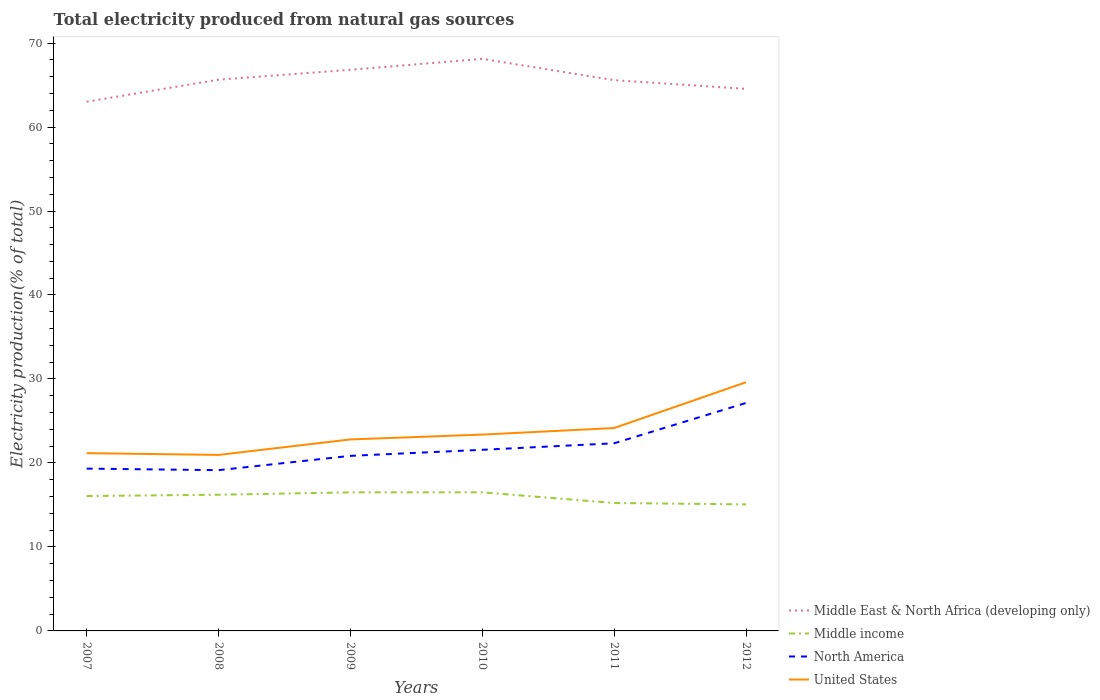How many different coloured lines are there?
Make the answer very short. 4. Does the line corresponding to Middle East & North Africa (developing only) intersect with the line corresponding to United States?
Your answer should be compact. No. Across all years, what is the maximum total electricity produced in North America?
Provide a short and direct response. 19.14. In which year was the total electricity produced in Middle East & North Africa (developing only) maximum?
Ensure brevity in your answer.  2007. What is the total total electricity produced in North America in the graph?
Provide a succinct answer. -4.8. What is the difference between the highest and the second highest total electricity produced in North America?
Your response must be concise. 8. How many lines are there?
Give a very brief answer. 4. How many years are there in the graph?
Make the answer very short. 6. Are the values on the major ticks of Y-axis written in scientific E-notation?
Offer a terse response. No. Does the graph contain grids?
Offer a terse response. No. Where does the legend appear in the graph?
Make the answer very short. Bottom right. How many legend labels are there?
Your answer should be very brief. 4. How are the legend labels stacked?
Your response must be concise. Vertical. What is the title of the graph?
Keep it short and to the point. Total electricity produced from natural gas sources. What is the label or title of the Y-axis?
Your answer should be compact. Electricity production(% of total). What is the Electricity production(% of total) in Middle East & North Africa (developing only) in 2007?
Provide a succinct answer. 63.01. What is the Electricity production(% of total) in Middle income in 2007?
Offer a very short reply. 16.06. What is the Electricity production(% of total) in North America in 2007?
Offer a terse response. 19.32. What is the Electricity production(% of total) of United States in 2007?
Your answer should be compact. 21.17. What is the Electricity production(% of total) in Middle East & North Africa (developing only) in 2008?
Give a very brief answer. 65.64. What is the Electricity production(% of total) in Middle income in 2008?
Offer a very short reply. 16.22. What is the Electricity production(% of total) of North America in 2008?
Give a very brief answer. 19.14. What is the Electricity production(% of total) of United States in 2008?
Keep it short and to the point. 20.96. What is the Electricity production(% of total) in Middle East & North Africa (developing only) in 2009?
Your answer should be compact. 66.81. What is the Electricity production(% of total) of Middle income in 2009?
Your answer should be compact. 16.5. What is the Electricity production(% of total) in North America in 2009?
Ensure brevity in your answer.  20.85. What is the Electricity production(% of total) of United States in 2009?
Ensure brevity in your answer.  22.8. What is the Electricity production(% of total) in Middle East & North Africa (developing only) in 2010?
Provide a short and direct response. 68.12. What is the Electricity production(% of total) in Middle income in 2010?
Offer a terse response. 16.5. What is the Electricity production(% of total) in North America in 2010?
Offer a terse response. 21.57. What is the Electricity production(% of total) in United States in 2010?
Your answer should be very brief. 23.38. What is the Electricity production(% of total) in Middle East & North Africa (developing only) in 2011?
Provide a short and direct response. 65.58. What is the Electricity production(% of total) of Middle income in 2011?
Give a very brief answer. 15.23. What is the Electricity production(% of total) in North America in 2011?
Offer a very short reply. 22.34. What is the Electricity production(% of total) in United States in 2011?
Ensure brevity in your answer.  24.16. What is the Electricity production(% of total) of Middle East & North Africa (developing only) in 2012?
Provide a succinct answer. 64.54. What is the Electricity production(% of total) of Middle income in 2012?
Offer a very short reply. 15.07. What is the Electricity production(% of total) in North America in 2012?
Make the answer very short. 27.15. What is the Electricity production(% of total) in United States in 2012?
Keep it short and to the point. 29.61. Across all years, what is the maximum Electricity production(% of total) of Middle East & North Africa (developing only)?
Your answer should be compact. 68.12. Across all years, what is the maximum Electricity production(% of total) of Middle income?
Provide a short and direct response. 16.5. Across all years, what is the maximum Electricity production(% of total) of North America?
Keep it short and to the point. 27.15. Across all years, what is the maximum Electricity production(% of total) of United States?
Provide a short and direct response. 29.61. Across all years, what is the minimum Electricity production(% of total) in Middle East & North Africa (developing only)?
Ensure brevity in your answer.  63.01. Across all years, what is the minimum Electricity production(% of total) in Middle income?
Keep it short and to the point. 15.07. Across all years, what is the minimum Electricity production(% of total) of North America?
Your answer should be very brief. 19.14. Across all years, what is the minimum Electricity production(% of total) of United States?
Offer a terse response. 20.96. What is the total Electricity production(% of total) of Middle East & North Africa (developing only) in the graph?
Give a very brief answer. 393.7. What is the total Electricity production(% of total) in Middle income in the graph?
Provide a short and direct response. 95.58. What is the total Electricity production(% of total) of North America in the graph?
Ensure brevity in your answer.  130.37. What is the total Electricity production(% of total) of United States in the graph?
Give a very brief answer. 142.07. What is the difference between the Electricity production(% of total) in Middle East & North Africa (developing only) in 2007 and that in 2008?
Offer a terse response. -2.63. What is the difference between the Electricity production(% of total) in Middle income in 2007 and that in 2008?
Provide a short and direct response. -0.16. What is the difference between the Electricity production(% of total) of North America in 2007 and that in 2008?
Give a very brief answer. 0.18. What is the difference between the Electricity production(% of total) of United States in 2007 and that in 2008?
Offer a terse response. 0.21. What is the difference between the Electricity production(% of total) in Middle East & North Africa (developing only) in 2007 and that in 2009?
Your answer should be compact. -3.8. What is the difference between the Electricity production(% of total) of Middle income in 2007 and that in 2009?
Your answer should be very brief. -0.44. What is the difference between the Electricity production(% of total) in North America in 2007 and that in 2009?
Provide a short and direct response. -1.52. What is the difference between the Electricity production(% of total) in United States in 2007 and that in 2009?
Give a very brief answer. -1.64. What is the difference between the Electricity production(% of total) in Middle East & North Africa (developing only) in 2007 and that in 2010?
Your answer should be very brief. -5.11. What is the difference between the Electricity production(% of total) of Middle income in 2007 and that in 2010?
Provide a succinct answer. -0.44. What is the difference between the Electricity production(% of total) of North America in 2007 and that in 2010?
Provide a succinct answer. -2.24. What is the difference between the Electricity production(% of total) of United States in 2007 and that in 2010?
Your answer should be compact. -2.21. What is the difference between the Electricity production(% of total) in Middle East & North Africa (developing only) in 2007 and that in 2011?
Offer a terse response. -2.57. What is the difference between the Electricity production(% of total) of Middle income in 2007 and that in 2011?
Your response must be concise. 0.83. What is the difference between the Electricity production(% of total) of North America in 2007 and that in 2011?
Ensure brevity in your answer.  -3.02. What is the difference between the Electricity production(% of total) of United States in 2007 and that in 2011?
Provide a short and direct response. -2.99. What is the difference between the Electricity production(% of total) of Middle East & North Africa (developing only) in 2007 and that in 2012?
Provide a succinct answer. -1.53. What is the difference between the Electricity production(% of total) of Middle income in 2007 and that in 2012?
Provide a short and direct response. 0.99. What is the difference between the Electricity production(% of total) in North America in 2007 and that in 2012?
Offer a terse response. -7.82. What is the difference between the Electricity production(% of total) of United States in 2007 and that in 2012?
Make the answer very short. -8.44. What is the difference between the Electricity production(% of total) of Middle East & North Africa (developing only) in 2008 and that in 2009?
Offer a terse response. -1.17. What is the difference between the Electricity production(% of total) in Middle income in 2008 and that in 2009?
Offer a terse response. -0.28. What is the difference between the Electricity production(% of total) in North America in 2008 and that in 2009?
Make the answer very short. -1.7. What is the difference between the Electricity production(% of total) of United States in 2008 and that in 2009?
Offer a terse response. -1.84. What is the difference between the Electricity production(% of total) of Middle East & North Africa (developing only) in 2008 and that in 2010?
Your response must be concise. -2.48. What is the difference between the Electricity production(% of total) in Middle income in 2008 and that in 2010?
Your answer should be compact. -0.29. What is the difference between the Electricity production(% of total) of North America in 2008 and that in 2010?
Offer a terse response. -2.42. What is the difference between the Electricity production(% of total) of United States in 2008 and that in 2010?
Provide a short and direct response. -2.42. What is the difference between the Electricity production(% of total) in Middle East & North Africa (developing only) in 2008 and that in 2011?
Give a very brief answer. 0.06. What is the difference between the Electricity production(% of total) of Middle income in 2008 and that in 2011?
Provide a short and direct response. 0.98. What is the difference between the Electricity production(% of total) of North America in 2008 and that in 2011?
Provide a succinct answer. -3.2. What is the difference between the Electricity production(% of total) in United States in 2008 and that in 2011?
Keep it short and to the point. -3.2. What is the difference between the Electricity production(% of total) of Middle East & North Africa (developing only) in 2008 and that in 2012?
Your answer should be compact. 1.09. What is the difference between the Electricity production(% of total) of Middle income in 2008 and that in 2012?
Make the answer very short. 1.15. What is the difference between the Electricity production(% of total) of North America in 2008 and that in 2012?
Offer a very short reply. -8. What is the difference between the Electricity production(% of total) in United States in 2008 and that in 2012?
Ensure brevity in your answer.  -8.65. What is the difference between the Electricity production(% of total) in Middle East & North Africa (developing only) in 2009 and that in 2010?
Your response must be concise. -1.3. What is the difference between the Electricity production(% of total) in Middle income in 2009 and that in 2010?
Provide a short and direct response. -0.01. What is the difference between the Electricity production(% of total) of North America in 2009 and that in 2010?
Give a very brief answer. -0.72. What is the difference between the Electricity production(% of total) of United States in 2009 and that in 2010?
Offer a very short reply. -0.57. What is the difference between the Electricity production(% of total) of Middle East & North Africa (developing only) in 2009 and that in 2011?
Provide a succinct answer. 1.23. What is the difference between the Electricity production(% of total) of Middle income in 2009 and that in 2011?
Your answer should be very brief. 1.27. What is the difference between the Electricity production(% of total) of North America in 2009 and that in 2011?
Ensure brevity in your answer.  -1.5. What is the difference between the Electricity production(% of total) of United States in 2009 and that in 2011?
Ensure brevity in your answer.  -1.36. What is the difference between the Electricity production(% of total) of Middle East & North Africa (developing only) in 2009 and that in 2012?
Your answer should be very brief. 2.27. What is the difference between the Electricity production(% of total) of Middle income in 2009 and that in 2012?
Your answer should be compact. 1.43. What is the difference between the Electricity production(% of total) of North America in 2009 and that in 2012?
Offer a terse response. -6.3. What is the difference between the Electricity production(% of total) in United States in 2009 and that in 2012?
Keep it short and to the point. -6.81. What is the difference between the Electricity production(% of total) of Middle East & North Africa (developing only) in 2010 and that in 2011?
Keep it short and to the point. 2.54. What is the difference between the Electricity production(% of total) in Middle income in 2010 and that in 2011?
Your answer should be very brief. 1.27. What is the difference between the Electricity production(% of total) of North America in 2010 and that in 2011?
Give a very brief answer. -0.78. What is the difference between the Electricity production(% of total) in United States in 2010 and that in 2011?
Ensure brevity in your answer.  -0.78. What is the difference between the Electricity production(% of total) in Middle East & North Africa (developing only) in 2010 and that in 2012?
Your answer should be compact. 3.57. What is the difference between the Electricity production(% of total) of Middle income in 2010 and that in 2012?
Make the answer very short. 1.44. What is the difference between the Electricity production(% of total) in North America in 2010 and that in 2012?
Make the answer very short. -5.58. What is the difference between the Electricity production(% of total) of United States in 2010 and that in 2012?
Provide a short and direct response. -6.23. What is the difference between the Electricity production(% of total) in Middle East & North Africa (developing only) in 2011 and that in 2012?
Your response must be concise. 1.04. What is the difference between the Electricity production(% of total) in Middle income in 2011 and that in 2012?
Provide a short and direct response. 0.16. What is the difference between the Electricity production(% of total) in North America in 2011 and that in 2012?
Your answer should be compact. -4.8. What is the difference between the Electricity production(% of total) of United States in 2011 and that in 2012?
Offer a very short reply. -5.45. What is the difference between the Electricity production(% of total) in Middle East & North Africa (developing only) in 2007 and the Electricity production(% of total) in Middle income in 2008?
Make the answer very short. 46.8. What is the difference between the Electricity production(% of total) in Middle East & North Africa (developing only) in 2007 and the Electricity production(% of total) in North America in 2008?
Make the answer very short. 43.87. What is the difference between the Electricity production(% of total) of Middle East & North Africa (developing only) in 2007 and the Electricity production(% of total) of United States in 2008?
Keep it short and to the point. 42.05. What is the difference between the Electricity production(% of total) of Middle income in 2007 and the Electricity production(% of total) of North America in 2008?
Make the answer very short. -3.08. What is the difference between the Electricity production(% of total) in Middle income in 2007 and the Electricity production(% of total) in United States in 2008?
Provide a succinct answer. -4.9. What is the difference between the Electricity production(% of total) of North America in 2007 and the Electricity production(% of total) of United States in 2008?
Offer a terse response. -1.63. What is the difference between the Electricity production(% of total) in Middle East & North Africa (developing only) in 2007 and the Electricity production(% of total) in Middle income in 2009?
Provide a short and direct response. 46.51. What is the difference between the Electricity production(% of total) of Middle East & North Africa (developing only) in 2007 and the Electricity production(% of total) of North America in 2009?
Ensure brevity in your answer.  42.16. What is the difference between the Electricity production(% of total) of Middle East & North Africa (developing only) in 2007 and the Electricity production(% of total) of United States in 2009?
Provide a succinct answer. 40.21. What is the difference between the Electricity production(% of total) in Middle income in 2007 and the Electricity production(% of total) in North America in 2009?
Make the answer very short. -4.79. What is the difference between the Electricity production(% of total) in Middle income in 2007 and the Electricity production(% of total) in United States in 2009?
Give a very brief answer. -6.74. What is the difference between the Electricity production(% of total) of North America in 2007 and the Electricity production(% of total) of United States in 2009?
Provide a short and direct response. -3.48. What is the difference between the Electricity production(% of total) of Middle East & North Africa (developing only) in 2007 and the Electricity production(% of total) of Middle income in 2010?
Provide a short and direct response. 46.51. What is the difference between the Electricity production(% of total) in Middle East & North Africa (developing only) in 2007 and the Electricity production(% of total) in North America in 2010?
Your answer should be compact. 41.45. What is the difference between the Electricity production(% of total) of Middle East & North Africa (developing only) in 2007 and the Electricity production(% of total) of United States in 2010?
Your response must be concise. 39.63. What is the difference between the Electricity production(% of total) of Middle income in 2007 and the Electricity production(% of total) of North America in 2010?
Keep it short and to the point. -5.51. What is the difference between the Electricity production(% of total) in Middle income in 2007 and the Electricity production(% of total) in United States in 2010?
Your answer should be very brief. -7.32. What is the difference between the Electricity production(% of total) in North America in 2007 and the Electricity production(% of total) in United States in 2010?
Your answer should be very brief. -4.05. What is the difference between the Electricity production(% of total) in Middle East & North Africa (developing only) in 2007 and the Electricity production(% of total) in Middle income in 2011?
Ensure brevity in your answer.  47.78. What is the difference between the Electricity production(% of total) in Middle East & North Africa (developing only) in 2007 and the Electricity production(% of total) in North America in 2011?
Offer a very short reply. 40.67. What is the difference between the Electricity production(% of total) of Middle East & North Africa (developing only) in 2007 and the Electricity production(% of total) of United States in 2011?
Ensure brevity in your answer.  38.85. What is the difference between the Electricity production(% of total) of Middle income in 2007 and the Electricity production(% of total) of North America in 2011?
Keep it short and to the point. -6.28. What is the difference between the Electricity production(% of total) of Middle income in 2007 and the Electricity production(% of total) of United States in 2011?
Offer a terse response. -8.1. What is the difference between the Electricity production(% of total) of North America in 2007 and the Electricity production(% of total) of United States in 2011?
Offer a terse response. -4.83. What is the difference between the Electricity production(% of total) in Middle East & North Africa (developing only) in 2007 and the Electricity production(% of total) in Middle income in 2012?
Your response must be concise. 47.94. What is the difference between the Electricity production(% of total) in Middle East & North Africa (developing only) in 2007 and the Electricity production(% of total) in North America in 2012?
Make the answer very short. 35.87. What is the difference between the Electricity production(% of total) of Middle East & North Africa (developing only) in 2007 and the Electricity production(% of total) of United States in 2012?
Keep it short and to the point. 33.4. What is the difference between the Electricity production(% of total) in Middle income in 2007 and the Electricity production(% of total) in North America in 2012?
Provide a short and direct response. -11.09. What is the difference between the Electricity production(% of total) of Middle income in 2007 and the Electricity production(% of total) of United States in 2012?
Keep it short and to the point. -13.55. What is the difference between the Electricity production(% of total) in North America in 2007 and the Electricity production(% of total) in United States in 2012?
Your answer should be very brief. -10.28. What is the difference between the Electricity production(% of total) in Middle East & North Africa (developing only) in 2008 and the Electricity production(% of total) in Middle income in 2009?
Your answer should be compact. 49.14. What is the difference between the Electricity production(% of total) in Middle East & North Africa (developing only) in 2008 and the Electricity production(% of total) in North America in 2009?
Your answer should be compact. 44.79. What is the difference between the Electricity production(% of total) in Middle East & North Africa (developing only) in 2008 and the Electricity production(% of total) in United States in 2009?
Offer a very short reply. 42.84. What is the difference between the Electricity production(% of total) in Middle income in 2008 and the Electricity production(% of total) in North America in 2009?
Offer a very short reply. -4.63. What is the difference between the Electricity production(% of total) in Middle income in 2008 and the Electricity production(% of total) in United States in 2009?
Make the answer very short. -6.59. What is the difference between the Electricity production(% of total) in North America in 2008 and the Electricity production(% of total) in United States in 2009?
Your answer should be very brief. -3.66. What is the difference between the Electricity production(% of total) of Middle East & North Africa (developing only) in 2008 and the Electricity production(% of total) of Middle income in 2010?
Your answer should be compact. 49.13. What is the difference between the Electricity production(% of total) of Middle East & North Africa (developing only) in 2008 and the Electricity production(% of total) of North America in 2010?
Keep it short and to the point. 44.07. What is the difference between the Electricity production(% of total) in Middle East & North Africa (developing only) in 2008 and the Electricity production(% of total) in United States in 2010?
Offer a very short reply. 42.26. What is the difference between the Electricity production(% of total) in Middle income in 2008 and the Electricity production(% of total) in North America in 2010?
Offer a terse response. -5.35. What is the difference between the Electricity production(% of total) in Middle income in 2008 and the Electricity production(% of total) in United States in 2010?
Give a very brief answer. -7.16. What is the difference between the Electricity production(% of total) in North America in 2008 and the Electricity production(% of total) in United States in 2010?
Your answer should be compact. -4.23. What is the difference between the Electricity production(% of total) of Middle East & North Africa (developing only) in 2008 and the Electricity production(% of total) of Middle income in 2011?
Give a very brief answer. 50.41. What is the difference between the Electricity production(% of total) in Middle East & North Africa (developing only) in 2008 and the Electricity production(% of total) in North America in 2011?
Keep it short and to the point. 43.3. What is the difference between the Electricity production(% of total) of Middle East & North Africa (developing only) in 2008 and the Electricity production(% of total) of United States in 2011?
Make the answer very short. 41.48. What is the difference between the Electricity production(% of total) in Middle income in 2008 and the Electricity production(% of total) in North America in 2011?
Ensure brevity in your answer.  -6.13. What is the difference between the Electricity production(% of total) in Middle income in 2008 and the Electricity production(% of total) in United States in 2011?
Offer a very short reply. -7.94. What is the difference between the Electricity production(% of total) of North America in 2008 and the Electricity production(% of total) of United States in 2011?
Make the answer very short. -5.02. What is the difference between the Electricity production(% of total) in Middle East & North Africa (developing only) in 2008 and the Electricity production(% of total) in Middle income in 2012?
Ensure brevity in your answer.  50.57. What is the difference between the Electricity production(% of total) of Middle East & North Africa (developing only) in 2008 and the Electricity production(% of total) of North America in 2012?
Give a very brief answer. 38.49. What is the difference between the Electricity production(% of total) of Middle East & North Africa (developing only) in 2008 and the Electricity production(% of total) of United States in 2012?
Make the answer very short. 36.03. What is the difference between the Electricity production(% of total) of Middle income in 2008 and the Electricity production(% of total) of North America in 2012?
Offer a terse response. -10.93. What is the difference between the Electricity production(% of total) in Middle income in 2008 and the Electricity production(% of total) in United States in 2012?
Keep it short and to the point. -13.39. What is the difference between the Electricity production(% of total) of North America in 2008 and the Electricity production(% of total) of United States in 2012?
Keep it short and to the point. -10.47. What is the difference between the Electricity production(% of total) in Middle East & North Africa (developing only) in 2009 and the Electricity production(% of total) in Middle income in 2010?
Give a very brief answer. 50.31. What is the difference between the Electricity production(% of total) of Middle East & North Africa (developing only) in 2009 and the Electricity production(% of total) of North America in 2010?
Your answer should be compact. 45.25. What is the difference between the Electricity production(% of total) in Middle East & North Africa (developing only) in 2009 and the Electricity production(% of total) in United States in 2010?
Your answer should be compact. 43.44. What is the difference between the Electricity production(% of total) of Middle income in 2009 and the Electricity production(% of total) of North America in 2010?
Give a very brief answer. -5.07. What is the difference between the Electricity production(% of total) of Middle income in 2009 and the Electricity production(% of total) of United States in 2010?
Your answer should be compact. -6.88. What is the difference between the Electricity production(% of total) of North America in 2009 and the Electricity production(% of total) of United States in 2010?
Your answer should be compact. -2.53. What is the difference between the Electricity production(% of total) in Middle East & North Africa (developing only) in 2009 and the Electricity production(% of total) in Middle income in 2011?
Give a very brief answer. 51.58. What is the difference between the Electricity production(% of total) in Middle East & North Africa (developing only) in 2009 and the Electricity production(% of total) in North America in 2011?
Your answer should be compact. 44.47. What is the difference between the Electricity production(% of total) in Middle East & North Africa (developing only) in 2009 and the Electricity production(% of total) in United States in 2011?
Your answer should be compact. 42.65. What is the difference between the Electricity production(% of total) of Middle income in 2009 and the Electricity production(% of total) of North America in 2011?
Offer a very short reply. -5.84. What is the difference between the Electricity production(% of total) in Middle income in 2009 and the Electricity production(% of total) in United States in 2011?
Keep it short and to the point. -7.66. What is the difference between the Electricity production(% of total) of North America in 2009 and the Electricity production(% of total) of United States in 2011?
Offer a terse response. -3.31. What is the difference between the Electricity production(% of total) in Middle East & North Africa (developing only) in 2009 and the Electricity production(% of total) in Middle income in 2012?
Keep it short and to the point. 51.74. What is the difference between the Electricity production(% of total) of Middle East & North Africa (developing only) in 2009 and the Electricity production(% of total) of North America in 2012?
Keep it short and to the point. 39.67. What is the difference between the Electricity production(% of total) of Middle East & North Africa (developing only) in 2009 and the Electricity production(% of total) of United States in 2012?
Provide a succinct answer. 37.2. What is the difference between the Electricity production(% of total) in Middle income in 2009 and the Electricity production(% of total) in North America in 2012?
Offer a very short reply. -10.65. What is the difference between the Electricity production(% of total) in Middle income in 2009 and the Electricity production(% of total) in United States in 2012?
Your response must be concise. -13.11. What is the difference between the Electricity production(% of total) of North America in 2009 and the Electricity production(% of total) of United States in 2012?
Provide a succinct answer. -8.76. What is the difference between the Electricity production(% of total) of Middle East & North Africa (developing only) in 2010 and the Electricity production(% of total) of Middle income in 2011?
Make the answer very short. 52.89. What is the difference between the Electricity production(% of total) of Middle East & North Africa (developing only) in 2010 and the Electricity production(% of total) of North America in 2011?
Provide a short and direct response. 45.77. What is the difference between the Electricity production(% of total) in Middle East & North Africa (developing only) in 2010 and the Electricity production(% of total) in United States in 2011?
Provide a short and direct response. 43.96. What is the difference between the Electricity production(% of total) in Middle income in 2010 and the Electricity production(% of total) in North America in 2011?
Your answer should be compact. -5.84. What is the difference between the Electricity production(% of total) in Middle income in 2010 and the Electricity production(% of total) in United States in 2011?
Your answer should be very brief. -7.65. What is the difference between the Electricity production(% of total) in North America in 2010 and the Electricity production(% of total) in United States in 2011?
Your answer should be compact. -2.59. What is the difference between the Electricity production(% of total) of Middle East & North Africa (developing only) in 2010 and the Electricity production(% of total) of Middle income in 2012?
Provide a short and direct response. 53.05. What is the difference between the Electricity production(% of total) in Middle East & North Africa (developing only) in 2010 and the Electricity production(% of total) in North America in 2012?
Provide a short and direct response. 40.97. What is the difference between the Electricity production(% of total) in Middle East & North Africa (developing only) in 2010 and the Electricity production(% of total) in United States in 2012?
Make the answer very short. 38.51. What is the difference between the Electricity production(% of total) in Middle income in 2010 and the Electricity production(% of total) in North America in 2012?
Your answer should be very brief. -10.64. What is the difference between the Electricity production(% of total) in Middle income in 2010 and the Electricity production(% of total) in United States in 2012?
Keep it short and to the point. -13.11. What is the difference between the Electricity production(% of total) of North America in 2010 and the Electricity production(% of total) of United States in 2012?
Your response must be concise. -8.04. What is the difference between the Electricity production(% of total) in Middle East & North Africa (developing only) in 2011 and the Electricity production(% of total) in Middle income in 2012?
Offer a very short reply. 50.51. What is the difference between the Electricity production(% of total) in Middle East & North Africa (developing only) in 2011 and the Electricity production(% of total) in North America in 2012?
Offer a very short reply. 38.43. What is the difference between the Electricity production(% of total) in Middle East & North Africa (developing only) in 2011 and the Electricity production(% of total) in United States in 2012?
Your answer should be compact. 35.97. What is the difference between the Electricity production(% of total) in Middle income in 2011 and the Electricity production(% of total) in North America in 2012?
Your response must be concise. -11.92. What is the difference between the Electricity production(% of total) in Middle income in 2011 and the Electricity production(% of total) in United States in 2012?
Your answer should be very brief. -14.38. What is the difference between the Electricity production(% of total) in North America in 2011 and the Electricity production(% of total) in United States in 2012?
Ensure brevity in your answer.  -7.27. What is the average Electricity production(% of total) of Middle East & North Africa (developing only) per year?
Your answer should be compact. 65.62. What is the average Electricity production(% of total) of Middle income per year?
Make the answer very short. 15.93. What is the average Electricity production(% of total) of North America per year?
Your answer should be very brief. 21.73. What is the average Electricity production(% of total) in United States per year?
Your answer should be very brief. 23.68. In the year 2007, what is the difference between the Electricity production(% of total) in Middle East & North Africa (developing only) and Electricity production(% of total) in Middle income?
Ensure brevity in your answer.  46.95. In the year 2007, what is the difference between the Electricity production(% of total) of Middle East & North Africa (developing only) and Electricity production(% of total) of North America?
Offer a terse response. 43.69. In the year 2007, what is the difference between the Electricity production(% of total) in Middle East & North Africa (developing only) and Electricity production(% of total) in United States?
Keep it short and to the point. 41.84. In the year 2007, what is the difference between the Electricity production(% of total) in Middle income and Electricity production(% of total) in North America?
Offer a very short reply. -3.26. In the year 2007, what is the difference between the Electricity production(% of total) of Middle income and Electricity production(% of total) of United States?
Make the answer very short. -5.11. In the year 2007, what is the difference between the Electricity production(% of total) of North America and Electricity production(% of total) of United States?
Ensure brevity in your answer.  -1.84. In the year 2008, what is the difference between the Electricity production(% of total) in Middle East & North Africa (developing only) and Electricity production(% of total) in Middle income?
Your answer should be very brief. 49.42. In the year 2008, what is the difference between the Electricity production(% of total) in Middle East & North Africa (developing only) and Electricity production(% of total) in North America?
Give a very brief answer. 46.5. In the year 2008, what is the difference between the Electricity production(% of total) in Middle East & North Africa (developing only) and Electricity production(% of total) in United States?
Your answer should be compact. 44.68. In the year 2008, what is the difference between the Electricity production(% of total) of Middle income and Electricity production(% of total) of North America?
Keep it short and to the point. -2.93. In the year 2008, what is the difference between the Electricity production(% of total) in Middle income and Electricity production(% of total) in United States?
Make the answer very short. -4.74. In the year 2008, what is the difference between the Electricity production(% of total) in North America and Electricity production(% of total) in United States?
Keep it short and to the point. -1.82. In the year 2009, what is the difference between the Electricity production(% of total) of Middle East & North Africa (developing only) and Electricity production(% of total) of Middle income?
Your answer should be very brief. 50.32. In the year 2009, what is the difference between the Electricity production(% of total) of Middle East & North Africa (developing only) and Electricity production(% of total) of North America?
Give a very brief answer. 45.97. In the year 2009, what is the difference between the Electricity production(% of total) in Middle East & North Africa (developing only) and Electricity production(% of total) in United States?
Your answer should be compact. 44.01. In the year 2009, what is the difference between the Electricity production(% of total) in Middle income and Electricity production(% of total) in North America?
Provide a short and direct response. -4.35. In the year 2009, what is the difference between the Electricity production(% of total) of Middle income and Electricity production(% of total) of United States?
Offer a very short reply. -6.3. In the year 2009, what is the difference between the Electricity production(% of total) in North America and Electricity production(% of total) in United States?
Keep it short and to the point. -1.96. In the year 2010, what is the difference between the Electricity production(% of total) of Middle East & North Africa (developing only) and Electricity production(% of total) of Middle income?
Provide a succinct answer. 51.61. In the year 2010, what is the difference between the Electricity production(% of total) of Middle East & North Africa (developing only) and Electricity production(% of total) of North America?
Provide a succinct answer. 46.55. In the year 2010, what is the difference between the Electricity production(% of total) of Middle East & North Africa (developing only) and Electricity production(% of total) of United States?
Provide a short and direct response. 44.74. In the year 2010, what is the difference between the Electricity production(% of total) of Middle income and Electricity production(% of total) of North America?
Offer a terse response. -5.06. In the year 2010, what is the difference between the Electricity production(% of total) of Middle income and Electricity production(% of total) of United States?
Offer a very short reply. -6.87. In the year 2010, what is the difference between the Electricity production(% of total) of North America and Electricity production(% of total) of United States?
Provide a short and direct response. -1.81. In the year 2011, what is the difference between the Electricity production(% of total) of Middle East & North Africa (developing only) and Electricity production(% of total) of Middle income?
Give a very brief answer. 50.35. In the year 2011, what is the difference between the Electricity production(% of total) of Middle East & North Africa (developing only) and Electricity production(% of total) of North America?
Your answer should be very brief. 43.24. In the year 2011, what is the difference between the Electricity production(% of total) in Middle East & North Africa (developing only) and Electricity production(% of total) in United States?
Provide a succinct answer. 41.42. In the year 2011, what is the difference between the Electricity production(% of total) of Middle income and Electricity production(% of total) of North America?
Your answer should be compact. -7.11. In the year 2011, what is the difference between the Electricity production(% of total) in Middle income and Electricity production(% of total) in United States?
Provide a short and direct response. -8.93. In the year 2011, what is the difference between the Electricity production(% of total) of North America and Electricity production(% of total) of United States?
Offer a terse response. -1.82. In the year 2012, what is the difference between the Electricity production(% of total) in Middle East & North Africa (developing only) and Electricity production(% of total) in Middle income?
Provide a succinct answer. 49.48. In the year 2012, what is the difference between the Electricity production(% of total) of Middle East & North Africa (developing only) and Electricity production(% of total) of North America?
Give a very brief answer. 37.4. In the year 2012, what is the difference between the Electricity production(% of total) of Middle East & North Africa (developing only) and Electricity production(% of total) of United States?
Your answer should be compact. 34.93. In the year 2012, what is the difference between the Electricity production(% of total) in Middle income and Electricity production(% of total) in North America?
Keep it short and to the point. -12.08. In the year 2012, what is the difference between the Electricity production(% of total) of Middle income and Electricity production(% of total) of United States?
Make the answer very short. -14.54. In the year 2012, what is the difference between the Electricity production(% of total) of North America and Electricity production(% of total) of United States?
Make the answer very short. -2.46. What is the ratio of the Electricity production(% of total) in Middle East & North Africa (developing only) in 2007 to that in 2008?
Keep it short and to the point. 0.96. What is the ratio of the Electricity production(% of total) in Middle income in 2007 to that in 2008?
Your response must be concise. 0.99. What is the ratio of the Electricity production(% of total) of North America in 2007 to that in 2008?
Provide a short and direct response. 1.01. What is the ratio of the Electricity production(% of total) in United States in 2007 to that in 2008?
Ensure brevity in your answer.  1.01. What is the ratio of the Electricity production(% of total) of Middle East & North Africa (developing only) in 2007 to that in 2009?
Offer a very short reply. 0.94. What is the ratio of the Electricity production(% of total) in Middle income in 2007 to that in 2009?
Your answer should be compact. 0.97. What is the ratio of the Electricity production(% of total) in North America in 2007 to that in 2009?
Provide a succinct answer. 0.93. What is the ratio of the Electricity production(% of total) of United States in 2007 to that in 2009?
Make the answer very short. 0.93. What is the ratio of the Electricity production(% of total) of Middle East & North Africa (developing only) in 2007 to that in 2010?
Your answer should be compact. 0.93. What is the ratio of the Electricity production(% of total) in Middle income in 2007 to that in 2010?
Offer a very short reply. 0.97. What is the ratio of the Electricity production(% of total) of North America in 2007 to that in 2010?
Give a very brief answer. 0.9. What is the ratio of the Electricity production(% of total) in United States in 2007 to that in 2010?
Your response must be concise. 0.91. What is the ratio of the Electricity production(% of total) of Middle East & North Africa (developing only) in 2007 to that in 2011?
Offer a terse response. 0.96. What is the ratio of the Electricity production(% of total) of Middle income in 2007 to that in 2011?
Offer a terse response. 1.05. What is the ratio of the Electricity production(% of total) in North America in 2007 to that in 2011?
Make the answer very short. 0.86. What is the ratio of the Electricity production(% of total) of United States in 2007 to that in 2011?
Keep it short and to the point. 0.88. What is the ratio of the Electricity production(% of total) of Middle East & North Africa (developing only) in 2007 to that in 2012?
Keep it short and to the point. 0.98. What is the ratio of the Electricity production(% of total) of Middle income in 2007 to that in 2012?
Your response must be concise. 1.07. What is the ratio of the Electricity production(% of total) in North America in 2007 to that in 2012?
Your answer should be very brief. 0.71. What is the ratio of the Electricity production(% of total) in United States in 2007 to that in 2012?
Provide a short and direct response. 0.71. What is the ratio of the Electricity production(% of total) of Middle East & North Africa (developing only) in 2008 to that in 2009?
Offer a terse response. 0.98. What is the ratio of the Electricity production(% of total) in Middle income in 2008 to that in 2009?
Provide a succinct answer. 0.98. What is the ratio of the Electricity production(% of total) in North America in 2008 to that in 2009?
Make the answer very short. 0.92. What is the ratio of the Electricity production(% of total) in United States in 2008 to that in 2009?
Your response must be concise. 0.92. What is the ratio of the Electricity production(% of total) in Middle East & North Africa (developing only) in 2008 to that in 2010?
Provide a short and direct response. 0.96. What is the ratio of the Electricity production(% of total) of Middle income in 2008 to that in 2010?
Make the answer very short. 0.98. What is the ratio of the Electricity production(% of total) of North America in 2008 to that in 2010?
Offer a very short reply. 0.89. What is the ratio of the Electricity production(% of total) in United States in 2008 to that in 2010?
Provide a succinct answer. 0.9. What is the ratio of the Electricity production(% of total) of Middle income in 2008 to that in 2011?
Keep it short and to the point. 1.06. What is the ratio of the Electricity production(% of total) of North America in 2008 to that in 2011?
Keep it short and to the point. 0.86. What is the ratio of the Electricity production(% of total) in United States in 2008 to that in 2011?
Your answer should be compact. 0.87. What is the ratio of the Electricity production(% of total) of Middle East & North Africa (developing only) in 2008 to that in 2012?
Give a very brief answer. 1.02. What is the ratio of the Electricity production(% of total) in Middle income in 2008 to that in 2012?
Your response must be concise. 1.08. What is the ratio of the Electricity production(% of total) of North America in 2008 to that in 2012?
Your response must be concise. 0.71. What is the ratio of the Electricity production(% of total) of United States in 2008 to that in 2012?
Give a very brief answer. 0.71. What is the ratio of the Electricity production(% of total) in Middle East & North Africa (developing only) in 2009 to that in 2010?
Offer a terse response. 0.98. What is the ratio of the Electricity production(% of total) in Middle income in 2009 to that in 2010?
Make the answer very short. 1. What is the ratio of the Electricity production(% of total) of North America in 2009 to that in 2010?
Offer a very short reply. 0.97. What is the ratio of the Electricity production(% of total) of United States in 2009 to that in 2010?
Offer a terse response. 0.98. What is the ratio of the Electricity production(% of total) in Middle East & North Africa (developing only) in 2009 to that in 2011?
Give a very brief answer. 1.02. What is the ratio of the Electricity production(% of total) of Middle income in 2009 to that in 2011?
Offer a very short reply. 1.08. What is the ratio of the Electricity production(% of total) of North America in 2009 to that in 2011?
Offer a very short reply. 0.93. What is the ratio of the Electricity production(% of total) of United States in 2009 to that in 2011?
Offer a very short reply. 0.94. What is the ratio of the Electricity production(% of total) of Middle East & North Africa (developing only) in 2009 to that in 2012?
Your response must be concise. 1.04. What is the ratio of the Electricity production(% of total) of Middle income in 2009 to that in 2012?
Your answer should be compact. 1.09. What is the ratio of the Electricity production(% of total) of North America in 2009 to that in 2012?
Offer a very short reply. 0.77. What is the ratio of the Electricity production(% of total) in United States in 2009 to that in 2012?
Your answer should be compact. 0.77. What is the ratio of the Electricity production(% of total) of Middle East & North Africa (developing only) in 2010 to that in 2011?
Give a very brief answer. 1.04. What is the ratio of the Electricity production(% of total) of Middle income in 2010 to that in 2011?
Your answer should be compact. 1.08. What is the ratio of the Electricity production(% of total) in North America in 2010 to that in 2011?
Provide a succinct answer. 0.97. What is the ratio of the Electricity production(% of total) in United States in 2010 to that in 2011?
Offer a very short reply. 0.97. What is the ratio of the Electricity production(% of total) of Middle East & North Africa (developing only) in 2010 to that in 2012?
Keep it short and to the point. 1.06. What is the ratio of the Electricity production(% of total) in Middle income in 2010 to that in 2012?
Your answer should be very brief. 1.1. What is the ratio of the Electricity production(% of total) in North America in 2010 to that in 2012?
Your response must be concise. 0.79. What is the ratio of the Electricity production(% of total) of United States in 2010 to that in 2012?
Offer a terse response. 0.79. What is the ratio of the Electricity production(% of total) in Middle East & North Africa (developing only) in 2011 to that in 2012?
Your response must be concise. 1.02. What is the ratio of the Electricity production(% of total) of Middle income in 2011 to that in 2012?
Provide a short and direct response. 1.01. What is the ratio of the Electricity production(% of total) of North America in 2011 to that in 2012?
Ensure brevity in your answer.  0.82. What is the ratio of the Electricity production(% of total) in United States in 2011 to that in 2012?
Keep it short and to the point. 0.82. What is the difference between the highest and the second highest Electricity production(% of total) in Middle East & North Africa (developing only)?
Provide a short and direct response. 1.3. What is the difference between the highest and the second highest Electricity production(% of total) in Middle income?
Your answer should be compact. 0.01. What is the difference between the highest and the second highest Electricity production(% of total) in North America?
Ensure brevity in your answer.  4.8. What is the difference between the highest and the second highest Electricity production(% of total) in United States?
Give a very brief answer. 5.45. What is the difference between the highest and the lowest Electricity production(% of total) in Middle East & North Africa (developing only)?
Give a very brief answer. 5.11. What is the difference between the highest and the lowest Electricity production(% of total) in Middle income?
Your answer should be very brief. 1.44. What is the difference between the highest and the lowest Electricity production(% of total) in North America?
Your response must be concise. 8. What is the difference between the highest and the lowest Electricity production(% of total) in United States?
Your response must be concise. 8.65. 